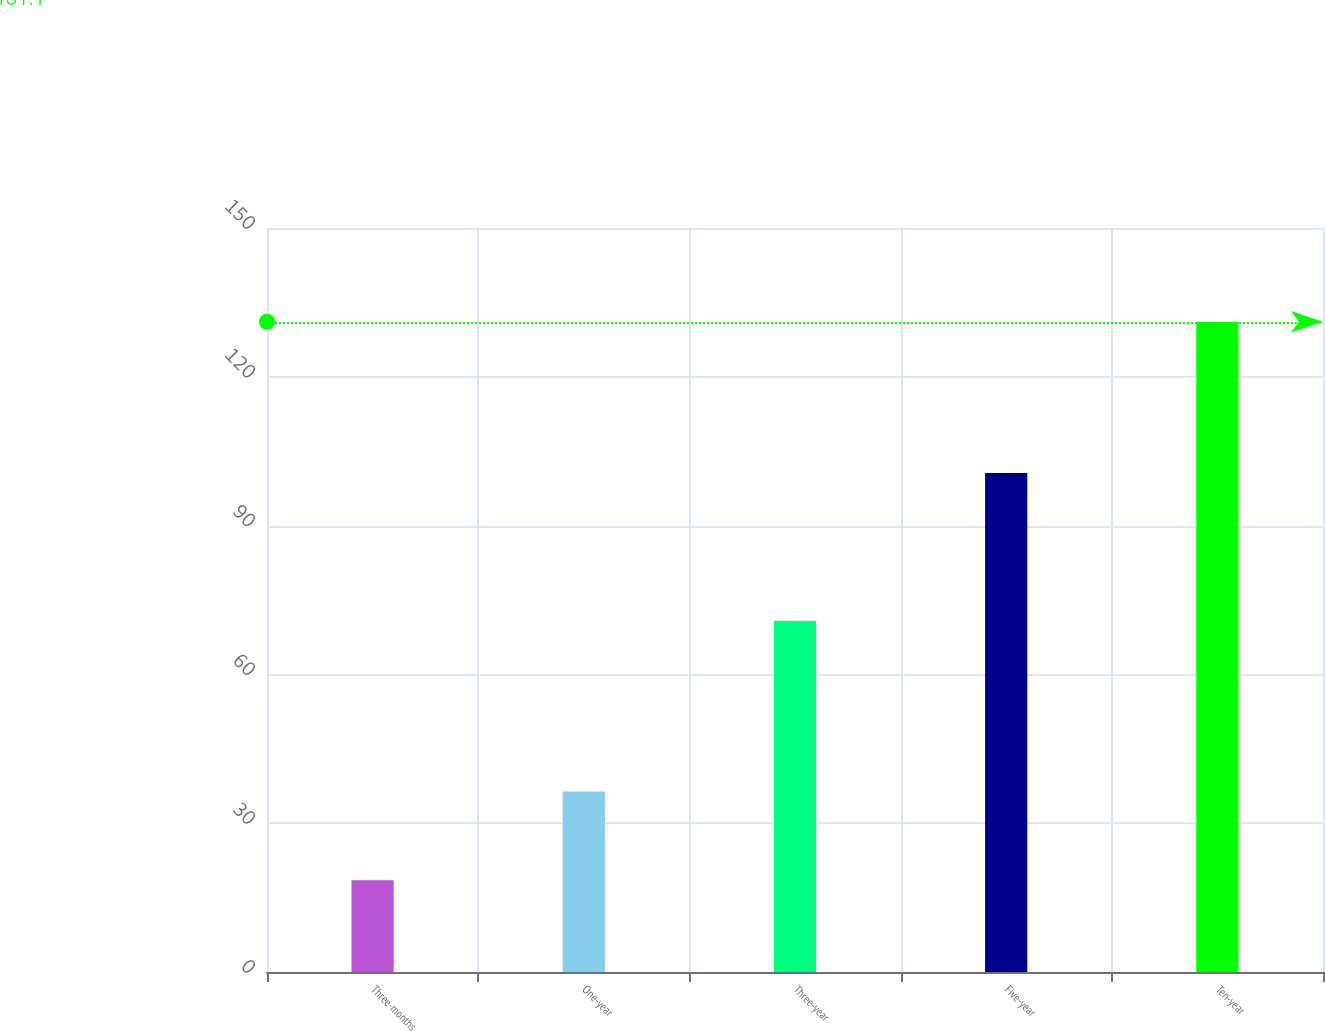Convert chart. <chart><loc_0><loc_0><loc_500><loc_500><bar_chart><fcel>Three-months<fcel>One-year<fcel>Three-year<fcel>Five-year<fcel>Ten-year<nl><fcel>18.5<fcel>36.4<fcel>70.8<fcel>100.6<fcel>131.1<nl></chart> 